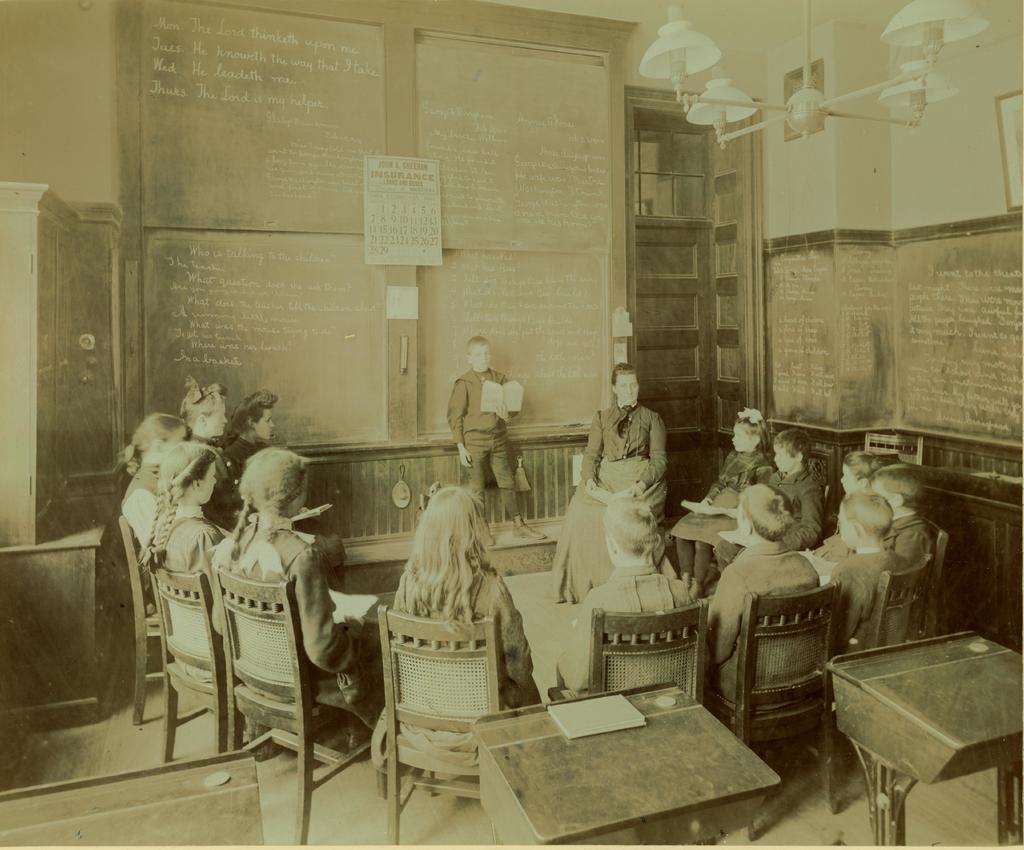How would you summarize this image in a sentence or two? This is a black and white image. I think this is a classroom where students can be seen discussing a topic. A boy is standing at the board looking into the book. This is the board. This is a calendar. These are lamps. All students are sitting in chairs. This is a table. On the right we can see walls. 